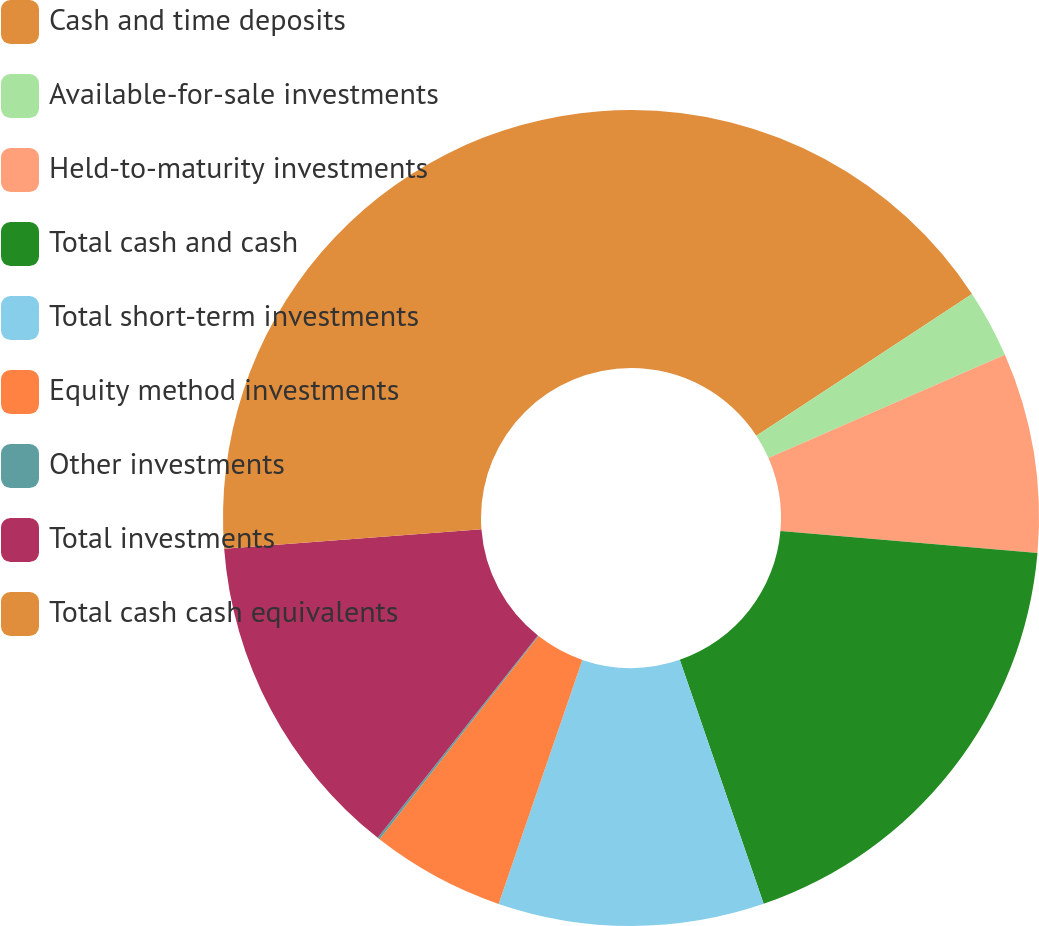Convert chart. <chart><loc_0><loc_0><loc_500><loc_500><pie_chart><fcel>Cash and time deposits<fcel>Available-for-sale investments<fcel>Held-to-maturity investments<fcel>Total cash and cash<fcel>Total short-term investments<fcel>Equity method investments<fcel>Other investments<fcel>Total investments<fcel>Total cash cash equivalents<nl><fcel>15.75%<fcel>2.7%<fcel>7.92%<fcel>18.36%<fcel>10.53%<fcel>5.31%<fcel>0.09%<fcel>13.14%<fcel>26.2%<nl></chart> 